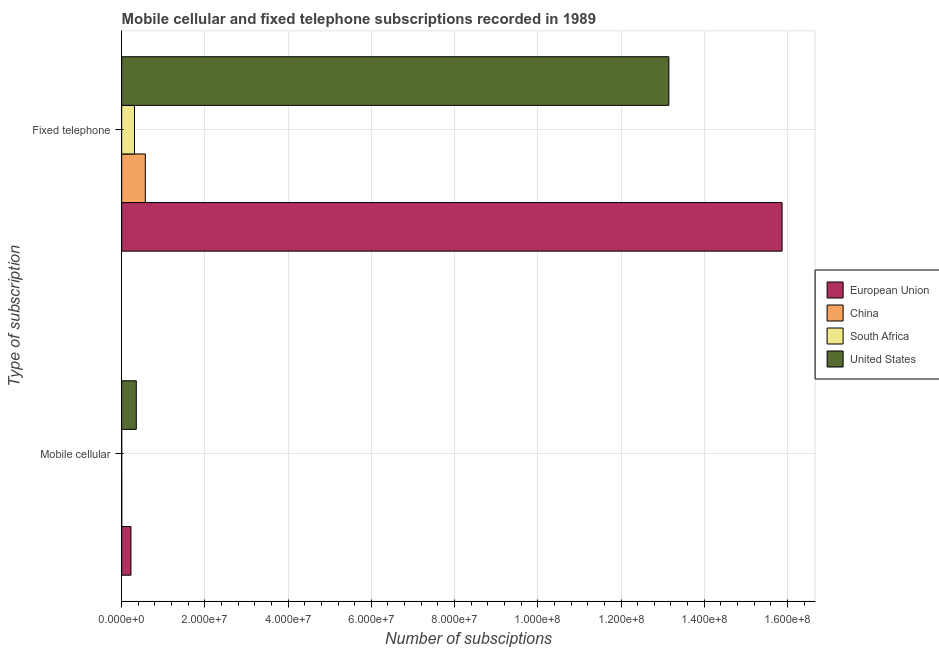How many different coloured bars are there?
Your answer should be compact. 4. How many groups of bars are there?
Your response must be concise. 2. Are the number of bars on each tick of the Y-axis equal?
Make the answer very short. Yes. How many bars are there on the 2nd tick from the bottom?
Offer a very short reply. 4. What is the label of the 1st group of bars from the top?
Provide a succinct answer. Fixed telephone. What is the number of fixed telephone subscriptions in South Africa?
Your answer should be compact. 3.08e+06. Across all countries, what is the maximum number of fixed telephone subscriptions?
Provide a short and direct response. 1.59e+08. Across all countries, what is the minimum number of fixed telephone subscriptions?
Keep it short and to the point. 3.08e+06. In which country was the number of mobile cellular subscriptions minimum?
Offer a very short reply. South Africa. What is the total number of fixed telephone subscriptions in the graph?
Offer a terse response. 2.99e+08. What is the difference between the number of mobile cellular subscriptions in South Africa and that in China?
Offer a very short reply. -5825. What is the difference between the number of mobile cellular subscriptions in South Africa and the number of fixed telephone subscriptions in United States?
Ensure brevity in your answer.  -1.32e+08. What is the average number of fixed telephone subscriptions per country?
Make the answer very short. 7.47e+07. What is the difference between the number of mobile cellular subscriptions and number of fixed telephone subscriptions in China?
Make the answer very short. -5.67e+06. What is the ratio of the number of fixed telephone subscriptions in China to that in South Africa?
Your response must be concise. 1.84. How many bars are there?
Offer a very short reply. 8. Does the graph contain any zero values?
Your answer should be very brief. No. Does the graph contain grids?
Give a very brief answer. Yes. Where does the legend appear in the graph?
Provide a short and direct response. Center right. How many legend labels are there?
Keep it short and to the point. 4. How are the legend labels stacked?
Your answer should be very brief. Vertical. What is the title of the graph?
Provide a succinct answer. Mobile cellular and fixed telephone subscriptions recorded in 1989. What is the label or title of the X-axis?
Make the answer very short. Number of subsciptions. What is the label or title of the Y-axis?
Your answer should be very brief. Type of subscription. What is the Number of subsciptions of European Union in Mobile cellular?
Your answer should be compact. 2.23e+06. What is the Number of subsciptions of China in Mobile cellular?
Your response must be concise. 9805. What is the Number of subsciptions of South Africa in Mobile cellular?
Offer a terse response. 3980. What is the Number of subsciptions in United States in Mobile cellular?
Ensure brevity in your answer.  3.51e+06. What is the Number of subsciptions of European Union in Fixed telephone?
Provide a succinct answer. 1.59e+08. What is the Number of subsciptions of China in Fixed telephone?
Make the answer very short. 5.68e+06. What is the Number of subsciptions of South Africa in Fixed telephone?
Your answer should be very brief. 3.08e+06. What is the Number of subsciptions of United States in Fixed telephone?
Offer a terse response. 1.32e+08. Across all Type of subscription, what is the maximum Number of subsciptions in European Union?
Offer a very short reply. 1.59e+08. Across all Type of subscription, what is the maximum Number of subsciptions in China?
Offer a terse response. 5.68e+06. Across all Type of subscription, what is the maximum Number of subsciptions of South Africa?
Offer a terse response. 3.08e+06. Across all Type of subscription, what is the maximum Number of subsciptions in United States?
Your answer should be compact. 1.32e+08. Across all Type of subscription, what is the minimum Number of subsciptions in European Union?
Offer a terse response. 2.23e+06. Across all Type of subscription, what is the minimum Number of subsciptions of China?
Your answer should be compact. 9805. Across all Type of subscription, what is the minimum Number of subsciptions in South Africa?
Your answer should be very brief. 3980. Across all Type of subscription, what is the minimum Number of subsciptions in United States?
Give a very brief answer. 3.51e+06. What is the total Number of subsciptions of European Union in the graph?
Your answer should be very brief. 1.61e+08. What is the total Number of subsciptions of China in the graph?
Provide a succinct answer. 5.69e+06. What is the total Number of subsciptions of South Africa in the graph?
Give a very brief answer. 3.08e+06. What is the total Number of subsciptions in United States in the graph?
Make the answer very short. 1.35e+08. What is the difference between the Number of subsciptions in European Union in Mobile cellular and that in Fixed telephone?
Offer a terse response. -1.56e+08. What is the difference between the Number of subsciptions in China in Mobile cellular and that in Fixed telephone?
Your answer should be compact. -5.67e+06. What is the difference between the Number of subsciptions of South Africa in Mobile cellular and that in Fixed telephone?
Keep it short and to the point. -3.08e+06. What is the difference between the Number of subsciptions of United States in Mobile cellular and that in Fixed telephone?
Provide a short and direct response. -1.28e+08. What is the difference between the Number of subsciptions in European Union in Mobile cellular and the Number of subsciptions in China in Fixed telephone?
Offer a terse response. -3.45e+06. What is the difference between the Number of subsciptions of European Union in Mobile cellular and the Number of subsciptions of South Africa in Fixed telephone?
Give a very brief answer. -8.49e+05. What is the difference between the Number of subsciptions of European Union in Mobile cellular and the Number of subsciptions of United States in Fixed telephone?
Offer a very short reply. -1.29e+08. What is the difference between the Number of subsciptions in China in Mobile cellular and the Number of subsciptions in South Africa in Fixed telephone?
Provide a succinct answer. -3.07e+06. What is the difference between the Number of subsciptions in China in Mobile cellular and the Number of subsciptions in United States in Fixed telephone?
Make the answer very short. -1.31e+08. What is the difference between the Number of subsciptions in South Africa in Mobile cellular and the Number of subsciptions in United States in Fixed telephone?
Your response must be concise. -1.32e+08. What is the average Number of subsciptions of European Union per Type of subscription?
Offer a terse response. 8.05e+07. What is the average Number of subsciptions in China per Type of subscription?
Offer a very short reply. 2.85e+06. What is the average Number of subsciptions in South Africa per Type of subscription?
Your answer should be very brief. 1.54e+06. What is the average Number of subsciptions in United States per Type of subscription?
Keep it short and to the point. 6.75e+07. What is the difference between the Number of subsciptions in European Union and Number of subsciptions in China in Mobile cellular?
Ensure brevity in your answer.  2.22e+06. What is the difference between the Number of subsciptions of European Union and Number of subsciptions of South Africa in Mobile cellular?
Keep it short and to the point. 2.23e+06. What is the difference between the Number of subsciptions in European Union and Number of subsciptions in United States in Mobile cellular?
Give a very brief answer. -1.28e+06. What is the difference between the Number of subsciptions in China and Number of subsciptions in South Africa in Mobile cellular?
Provide a succinct answer. 5825. What is the difference between the Number of subsciptions in China and Number of subsciptions in United States in Mobile cellular?
Make the answer very short. -3.50e+06. What is the difference between the Number of subsciptions in South Africa and Number of subsciptions in United States in Mobile cellular?
Make the answer very short. -3.50e+06. What is the difference between the Number of subsciptions of European Union and Number of subsciptions of China in Fixed telephone?
Your answer should be compact. 1.53e+08. What is the difference between the Number of subsciptions in European Union and Number of subsciptions in South Africa in Fixed telephone?
Your answer should be compact. 1.56e+08. What is the difference between the Number of subsciptions in European Union and Number of subsciptions in United States in Fixed telephone?
Offer a terse response. 2.72e+07. What is the difference between the Number of subsciptions of China and Number of subsciptions of South Africa in Fixed telephone?
Your answer should be compact. 2.60e+06. What is the difference between the Number of subsciptions of China and Number of subsciptions of United States in Fixed telephone?
Your answer should be very brief. -1.26e+08. What is the difference between the Number of subsciptions of South Africa and Number of subsciptions of United States in Fixed telephone?
Offer a terse response. -1.28e+08. What is the ratio of the Number of subsciptions of European Union in Mobile cellular to that in Fixed telephone?
Offer a terse response. 0.01. What is the ratio of the Number of subsciptions in China in Mobile cellular to that in Fixed telephone?
Provide a short and direct response. 0. What is the ratio of the Number of subsciptions in South Africa in Mobile cellular to that in Fixed telephone?
Provide a succinct answer. 0. What is the ratio of the Number of subsciptions of United States in Mobile cellular to that in Fixed telephone?
Keep it short and to the point. 0.03. What is the difference between the highest and the second highest Number of subsciptions in European Union?
Provide a short and direct response. 1.56e+08. What is the difference between the highest and the second highest Number of subsciptions of China?
Give a very brief answer. 5.67e+06. What is the difference between the highest and the second highest Number of subsciptions in South Africa?
Ensure brevity in your answer.  3.08e+06. What is the difference between the highest and the second highest Number of subsciptions of United States?
Offer a terse response. 1.28e+08. What is the difference between the highest and the lowest Number of subsciptions of European Union?
Your response must be concise. 1.56e+08. What is the difference between the highest and the lowest Number of subsciptions of China?
Your response must be concise. 5.67e+06. What is the difference between the highest and the lowest Number of subsciptions in South Africa?
Offer a terse response. 3.08e+06. What is the difference between the highest and the lowest Number of subsciptions in United States?
Your response must be concise. 1.28e+08. 